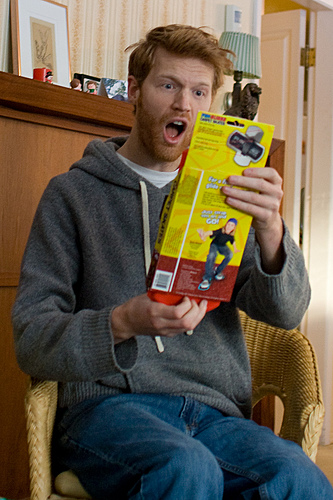<image>
Can you confirm if the man is next to the product? Yes. The man is positioned adjacent to the product, located nearby in the same general area. Is the chair next to the door? Yes. The chair is positioned adjacent to the door, located nearby in the same general area. 